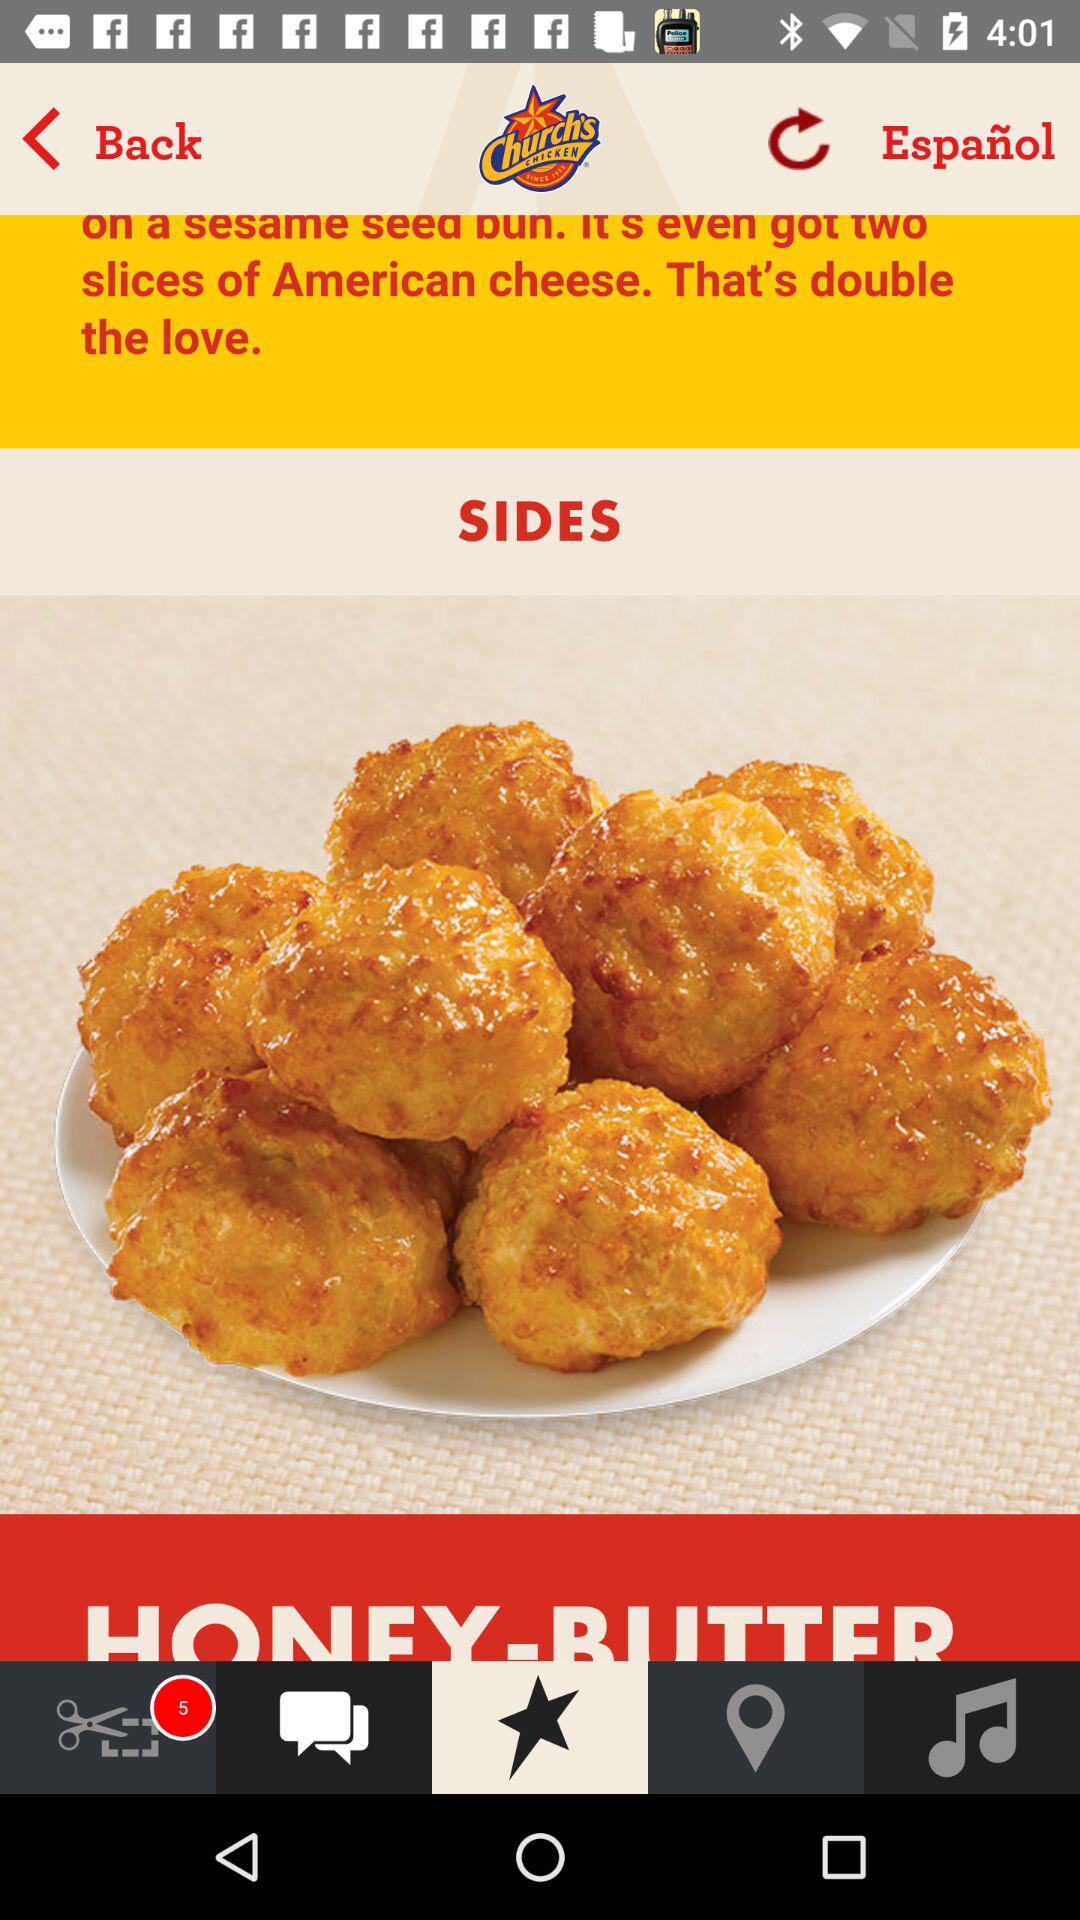How many slices of American cheese are added? There are two slices of American cheese added. 